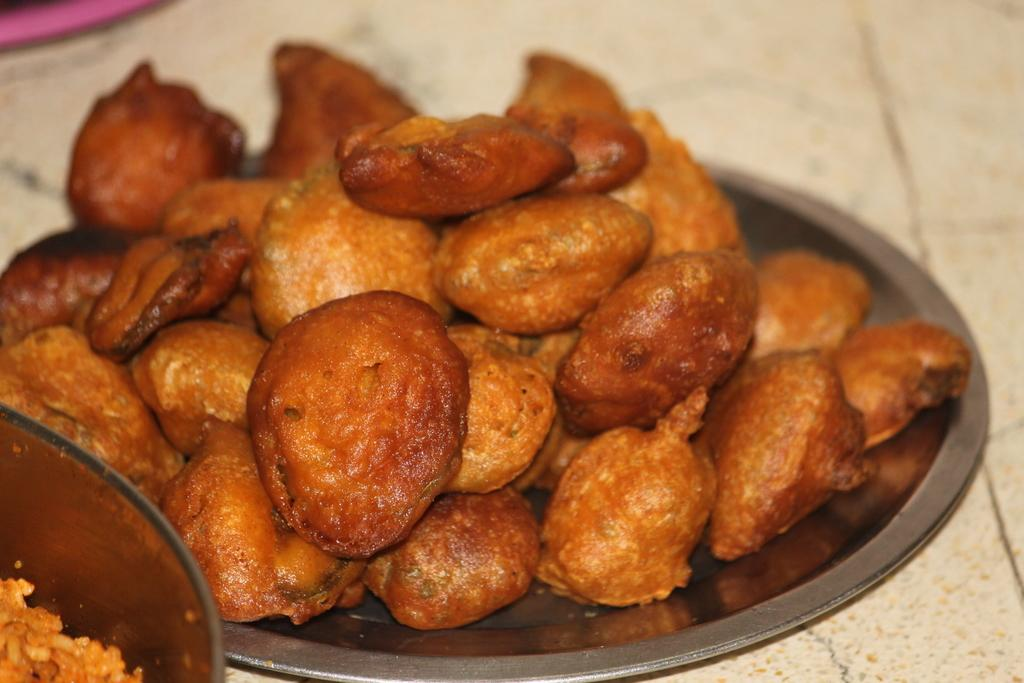What is present on the plate in the image? There is food in a plate in the image. Where is the quiver located in the image? There is no quiver present in the image. What type of plastic is used to make the bedroom furniture in the image? There is no bedroom furniture present in the image, and therefore no plastic can be identified. 